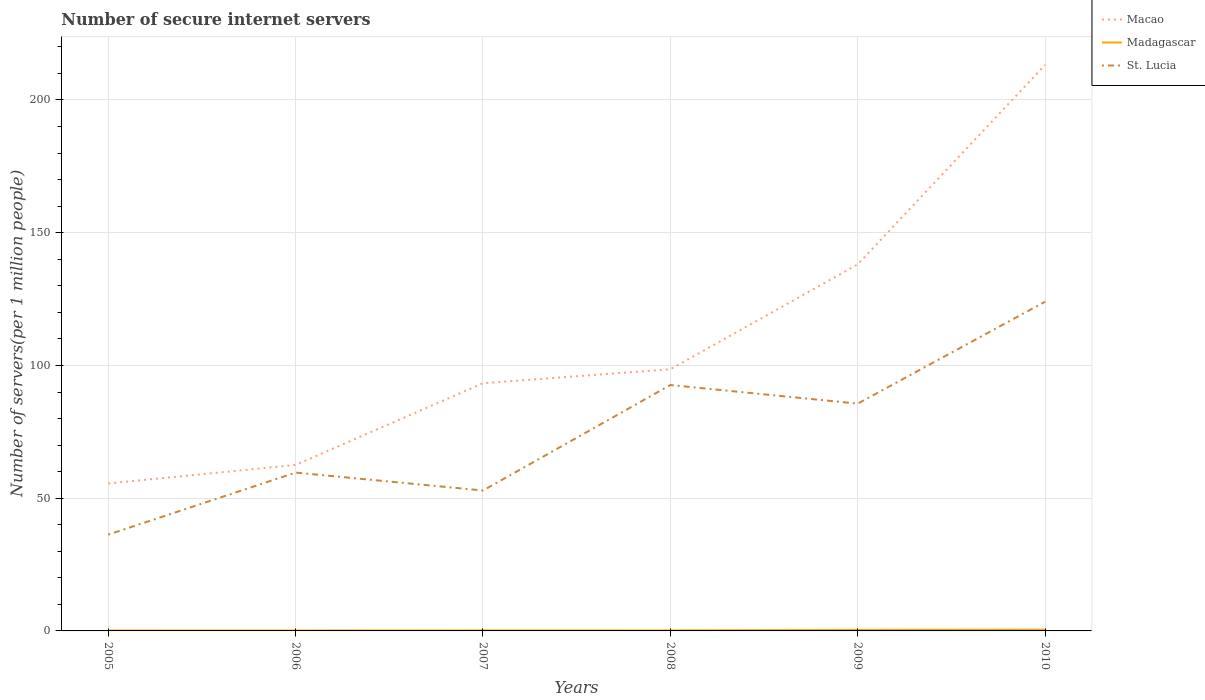How many different coloured lines are there?
Your answer should be compact. 3. Does the line corresponding to St. Lucia intersect with the line corresponding to Macao?
Provide a succinct answer. No. Across all years, what is the maximum number of secure internet servers in St. Lucia?
Keep it short and to the point. 36.27. What is the total number of secure internet servers in Macao in the graph?
Your answer should be very brief. -119.93. What is the difference between the highest and the second highest number of secure internet servers in St. Lucia?
Offer a terse response. 87.74. How many lines are there?
Offer a terse response. 3. How many years are there in the graph?
Keep it short and to the point. 6. Does the graph contain grids?
Provide a succinct answer. Yes. How are the legend labels stacked?
Your answer should be compact. Vertical. What is the title of the graph?
Your answer should be compact. Number of secure internet servers. Does "Latin America(developing only)" appear as one of the legend labels in the graph?
Offer a terse response. No. What is the label or title of the Y-axis?
Your answer should be compact. Number of servers(per 1 million people). What is the Number of servers(per 1 million people) in Macao in 2005?
Give a very brief answer. 55.54. What is the Number of servers(per 1 million people) of Madagascar in 2005?
Your answer should be very brief. 0.16. What is the Number of servers(per 1 million people) in St. Lucia in 2005?
Offer a terse response. 36.27. What is the Number of servers(per 1 million people) of Macao in 2006?
Your response must be concise. 62.54. What is the Number of servers(per 1 million people) in Madagascar in 2006?
Keep it short and to the point. 0.16. What is the Number of servers(per 1 million people) in St. Lucia in 2006?
Offer a very short reply. 59.65. What is the Number of servers(per 1 million people) in Macao in 2007?
Keep it short and to the point. 93.3. What is the Number of servers(per 1 million people) in Madagascar in 2007?
Offer a very short reply. 0.21. What is the Number of servers(per 1 million people) of St. Lucia in 2007?
Ensure brevity in your answer.  52.9. What is the Number of servers(per 1 million people) of Macao in 2008?
Your answer should be compact. 98.57. What is the Number of servers(per 1 million people) in Madagascar in 2008?
Give a very brief answer. 0.2. What is the Number of servers(per 1 million people) of St. Lucia in 2008?
Provide a succinct answer. 92.63. What is the Number of servers(per 1 million people) in Macao in 2009?
Give a very brief answer. 138.09. What is the Number of servers(per 1 million people) in Madagascar in 2009?
Make the answer very short. 0.39. What is the Number of servers(per 1 million people) of St. Lucia in 2009?
Offer a very short reply. 85.62. What is the Number of servers(per 1 million people) in Macao in 2010?
Provide a succinct answer. 213.23. What is the Number of servers(per 1 million people) in Madagascar in 2010?
Offer a terse response. 0.47. What is the Number of servers(per 1 million people) in St. Lucia in 2010?
Offer a terse response. 124.02. Across all years, what is the maximum Number of servers(per 1 million people) in Macao?
Keep it short and to the point. 213.23. Across all years, what is the maximum Number of servers(per 1 million people) in Madagascar?
Ensure brevity in your answer.  0.47. Across all years, what is the maximum Number of servers(per 1 million people) in St. Lucia?
Keep it short and to the point. 124.02. Across all years, what is the minimum Number of servers(per 1 million people) in Macao?
Provide a succinct answer. 55.54. Across all years, what is the minimum Number of servers(per 1 million people) in Madagascar?
Offer a terse response. 0.16. Across all years, what is the minimum Number of servers(per 1 million people) in St. Lucia?
Provide a succinct answer. 36.27. What is the total Number of servers(per 1 million people) in Macao in the graph?
Make the answer very short. 661.26. What is the total Number of servers(per 1 million people) of Madagascar in the graph?
Provide a short and direct response. 1.6. What is the total Number of servers(per 1 million people) of St. Lucia in the graph?
Your response must be concise. 451.08. What is the difference between the Number of servers(per 1 million people) in Macao in 2005 and that in 2006?
Offer a very short reply. -7. What is the difference between the Number of servers(per 1 million people) in Madagascar in 2005 and that in 2006?
Provide a succinct answer. 0. What is the difference between the Number of servers(per 1 million people) of St. Lucia in 2005 and that in 2006?
Ensure brevity in your answer.  -23.37. What is the difference between the Number of servers(per 1 million people) of Macao in 2005 and that in 2007?
Offer a terse response. -37.76. What is the difference between the Number of servers(per 1 million people) in Madagascar in 2005 and that in 2007?
Make the answer very short. -0.04. What is the difference between the Number of servers(per 1 million people) in St. Lucia in 2005 and that in 2007?
Keep it short and to the point. -16.62. What is the difference between the Number of servers(per 1 million people) of Macao in 2005 and that in 2008?
Your answer should be compact. -43.03. What is the difference between the Number of servers(per 1 million people) in Madagascar in 2005 and that in 2008?
Give a very brief answer. -0.04. What is the difference between the Number of servers(per 1 million people) in St. Lucia in 2005 and that in 2008?
Your answer should be very brief. -56.36. What is the difference between the Number of servers(per 1 million people) of Macao in 2005 and that in 2009?
Offer a very short reply. -82.55. What is the difference between the Number of servers(per 1 million people) in Madagascar in 2005 and that in 2009?
Your answer should be very brief. -0.23. What is the difference between the Number of servers(per 1 million people) of St. Lucia in 2005 and that in 2009?
Make the answer very short. -49.34. What is the difference between the Number of servers(per 1 million people) in Macao in 2005 and that in 2010?
Your response must be concise. -157.7. What is the difference between the Number of servers(per 1 million people) in Madagascar in 2005 and that in 2010?
Make the answer very short. -0.31. What is the difference between the Number of servers(per 1 million people) in St. Lucia in 2005 and that in 2010?
Your answer should be very brief. -87.74. What is the difference between the Number of servers(per 1 million people) in Macao in 2006 and that in 2007?
Offer a terse response. -30.77. What is the difference between the Number of servers(per 1 million people) of Madagascar in 2006 and that in 2007?
Offer a very short reply. -0.05. What is the difference between the Number of servers(per 1 million people) of St. Lucia in 2006 and that in 2007?
Your response must be concise. 6.75. What is the difference between the Number of servers(per 1 million people) of Macao in 2006 and that in 2008?
Make the answer very short. -36.03. What is the difference between the Number of servers(per 1 million people) of Madagascar in 2006 and that in 2008?
Provide a short and direct response. -0.04. What is the difference between the Number of servers(per 1 million people) of St. Lucia in 2006 and that in 2008?
Your response must be concise. -32.98. What is the difference between the Number of servers(per 1 million people) in Macao in 2006 and that in 2009?
Ensure brevity in your answer.  -75.55. What is the difference between the Number of servers(per 1 million people) of Madagascar in 2006 and that in 2009?
Offer a terse response. -0.23. What is the difference between the Number of servers(per 1 million people) of St. Lucia in 2006 and that in 2009?
Make the answer very short. -25.97. What is the difference between the Number of servers(per 1 million people) of Macao in 2006 and that in 2010?
Make the answer very short. -150.7. What is the difference between the Number of servers(per 1 million people) of Madagascar in 2006 and that in 2010?
Give a very brief answer. -0.32. What is the difference between the Number of servers(per 1 million people) of St. Lucia in 2006 and that in 2010?
Ensure brevity in your answer.  -64.37. What is the difference between the Number of servers(per 1 million people) of Macao in 2007 and that in 2008?
Your response must be concise. -5.26. What is the difference between the Number of servers(per 1 million people) in Madagascar in 2007 and that in 2008?
Make the answer very short. 0.01. What is the difference between the Number of servers(per 1 million people) in St. Lucia in 2007 and that in 2008?
Provide a succinct answer. -39.73. What is the difference between the Number of servers(per 1 million people) in Macao in 2007 and that in 2009?
Make the answer very short. -44.79. What is the difference between the Number of servers(per 1 million people) in Madagascar in 2007 and that in 2009?
Provide a succinct answer. -0.18. What is the difference between the Number of servers(per 1 million people) of St. Lucia in 2007 and that in 2009?
Give a very brief answer. -32.72. What is the difference between the Number of servers(per 1 million people) of Macao in 2007 and that in 2010?
Ensure brevity in your answer.  -119.93. What is the difference between the Number of servers(per 1 million people) in Madagascar in 2007 and that in 2010?
Your answer should be compact. -0.27. What is the difference between the Number of servers(per 1 million people) in St. Lucia in 2007 and that in 2010?
Ensure brevity in your answer.  -71.12. What is the difference between the Number of servers(per 1 million people) in Macao in 2008 and that in 2009?
Make the answer very short. -39.52. What is the difference between the Number of servers(per 1 million people) of Madagascar in 2008 and that in 2009?
Provide a succinct answer. -0.19. What is the difference between the Number of servers(per 1 million people) of St. Lucia in 2008 and that in 2009?
Make the answer very short. 7.01. What is the difference between the Number of servers(per 1 million people) of Macao in 2008 and that in 2010?
Provide a short and direct response. -114.67. What is the difference between the Number of servers(per 1 million people) of Madagascar in 2008 and that in 2010?
Provide a succinct answer. -0.27. What is the difference between the Number of servers(per 1 million people) in St. Lucia in 2008 and that in 2010?
Your response must be concise. -31.39. What is the difference between the Number of servers(per 1 million people) of Macao in 2009 and that in 2010?
Give a very brief answer. -75.14. What is the difference between the Number of servers(per 1 million people) of Madagascar in 2009 and that in 2010?
Your response must be concise. -0.08. What is the difference between the Number of servers(per 1 million people) of St. Lucia in 2009 and that in 2010?
Your response must be concise. -38.4. What is the difference between the Number of servers(per 1 million people) of Macao in 2005 and the Number of servers(per 1 million people) of Madagascar in 2006?
Your answer should be very brief. 55.38. What is the difference between the Number of servers(per 1 million people) in Macao in 2005 and the Number of servers(per 1 million people) in St. Lucia in 2006?
Your response must be concise. -4.11. What is the difference between the Number of servers(per 1 million people) of Madagascar in 2005 and the Number of servers(per 1 million people) of St. Lucia in 2006?
Your answer should be very brief. -59.48. What is the difference between the Number of servers(per 1 million people) in Macao in 2005 and the Number of servers(per 1 million people) in Madagascar in 2007?
Ensure brevity in your answer.  55.33. What is the difference between the Number of servers(per 1 million people) of Macao in 2005 and the Number of servers(per 1 million people) of St. Lucia in 2007?
Make the answer very short. 2.64. What is the difference between the Number of servers(per 1 million people) in Madagascar in 2005 and the Number of servers(per 1 million people) in St. Lucia in 2007?
Offer a terse response. -52.73. What is the difference between the Number of servers(per 1 million people) of Macao in 2005 and the Number of servers(per 1 million people) of Madagascar in 2008?
Provide a short and direct response. 55.34. What is the difference between the Number of servers(per 1 million people) in Macao in 2005 and the Number of servers(per 1 million people) in St. Lucia in 2008?
Offer a very short reply. -37.09. What is the difference between the Number of servers(per 1 million people) of Madagascar in 2005 and the Number of servers(per 1 million people) of St. Lucia in 2008?
Provide a short and direct response. -92.47. What is the difference between the Number of servers(per 1 million people) of Macao in 2005 and the Number of servers(per 1 million people) of Madagascar in 2009?
Ensure brevity in your answer.  55.15. What is the difference between the Number of servers(per 1 million people) of Macao in 2005 and the Number of servers(per 1 million people) of St. Lucia in 2009?
Keep it short and to the point. -30.08. What is the difference between the Number of servers(per 1 million people) of Madagascar in 2005 and the Number of servers(per 1 million people) of St. Lucia in 2009?
Give a very brief answer. -85.45. What is the difference between the Number of servers(per 1 million people) in Macao in 2005 and the Number of servers(per 1 million people) in Madagascar in 2010?
Give a very brief answer. 55.06. What is the difference between the Number of servers(per 1 million people) in Macao in 2005 and the Number of servers(per 1 million people) in St. Lucia in 2010?
Your response must be concise. -68.48. What is the difference between the Number of servers(per 1 million people) of Madagascar in 2005 and the Number of servers(per 1 million people) of St. Lucia in 2010?
Offer a very short reply. -123.85. What is the difference between the Number of servers(per 1 million people) in Macao in 2006 and the Number of servers(per 1 million people) in Madagascar in 2007?
Offer a terse response. 62.33. What is the difference between the Number of servers(per 1 million people) of Macao in 2006 and the Number of servers(per 1 million people) of St. Lucia in 2007?
Provide a short and direct response. 9.64. What is the difference between the Number of servers(per 1 million people) of Madagascar in 2006 and the Number of servers(per 1 million people) of St. Lucia in 2007?
Offer a very short reply. -52.74. What is the difference between the Number of servers(per 1 million people) of Macao in 2006 and the Number of servers(per 1 million people) of Madagascar in 2008?
Ensure brevity in your answer.  62.33. What is the difference between the Number of servers(per 1 million people) of Macao in 2006 and the Number of servers(per 1 million people) of St. Lucia in 2008?
Offer a very short reply. -30.1. What is the difference between the Number of servers(per 1 million people) in Madagascar in 2006 and the Number of servers(per 1 million people) in St. Lucia in 2008?
Keep it short and to the point. -92.47. What is the difference between the Number of servers(per 1 million people) of Macao in 2006 and the Number of servers(per 1 million people) of Madagascar in 2009?
Provide a short and direct response. 62.15. What is the difference between the Number of servers(per 1 million people) of Macao in 2006 and the Number of servers(per 1 million people) of St. Lucia in 2009?
Your answer should be very brief. -23.08. What is the difference between the Number of servers(per 1 million people) of Madagascar in 2006 and the Number of servers(per 1 million people) of St. Lucia in 2009?
Make the answer very short. -85.46. What is the difference between the Number of servers(per 1 million people) in Macao in 2006 and the Number of servers(per 1 million people) in Madagascar in 2010?
Ensure brevity in your answer.  62.06. What is the difference between the Number of servers(per 1 million people) of Macao in 2006 and the Number of servers(per 1 million people) of St. Lucia in 2010?
Keep it short and to the point. -61.48. What is the difference between the Number of servers(per 1 million people) in Madagascar in 2006 and the Number of servers(per 1 million people) in St. Lucia in 2010?
Provide a short and direct response. -123.86. What is the difference between the Number of servers(per 1 million people) of Macao in 2007 and the Number of servers(per 1 million people) of Madagascar in 2008?
Offer a very short reply. 93.1. What is the difference between the Number of servers(per 1 million people) in Macao in 2007 and the Number of servers(per 1 million people) in St. Lucia in 2008?
Provide a succinct answer. 0.67. What is the difference between the Number of servers(per 1 million people) in Madagascar in 2007 and the Number of servers(per 1 million people) in St. Lucia in 2008?
Offer a very short reply. -92.42. What is the difference between the Number of servers(per 1 million people) of Macao in 2007 and the Number of servers(per 1 million people) of Madagascar in 2009?
Provide a succinct answer. 92.91. What is the difference between the Number of servers(per 1 million people) in Macao in 2007 and the Number of servers(per 1 million people) in St. Lucia in 2009?
Keep it short and to the point. 7.68. What is the difference between the Number of servers(per 1 million people) of Madagascar in 2007 and the Number of servers(per 1 million people) of St. Lucia in 2009?
Offer a terse response. -85.41. What is the difference between the Number of servers(per 1 million people) in Macao in 2007 and the Number of servers(per 1 million people) in Madagascar in 2010?
Provide a succinct answer. 92.83. What is the difference between the Number of servers(per 1 million people) in Macao in 2007 and the Number of servers(per 1 million people) in St. Lucia in 2010?
Offer a very short reply. -30.71. What is the difference between the Number of servers(per 1 million people) of Madagascar in 2007 and the Number of servers(per 1 million people) of St. Lucia in 2010?
Make the answer very short. -123.81. What is the difference between the Number of servers(per 1 million people) in Macao in 2008 and the Number of servers(per 1 million people) in Madagascar in 2009?
Provide a short and direct response. 98.18. What is the difference between the Number of servers(per 1 million people) of Macao in 2008 and the Number of servers(per 1 million people) of St. Lucia in 2009?
Your response must be concise. 12.95. What is the difference between the Number of servers(per 1 million people) of Madagascar in 2008 and the Number of servers(per 1 million people) of St. Lucia in 2009?
Your answer should be very brief. -85.42. What is the difference between the Number of servers(per 1 million people) in Macao in 2008 and the Number of servers(per 1 million people) in Madagascar in 2010?
Give a very brief answer. 98.09. What is the difference between the Number of servers(per 1 million people) of Macao in 2008 and the Number of servers(per 1 million people) of St. Lucia in 2010?
Make the answer very short. -25.45. What is the difference between the Number of servers(per 1 million people) of Madagascar in 2008 and the Number of servers(per 1 million people) of St. Lucia in 2010?
Make the answer very short. -123.81. What is the difference between the Number of servers(per 1 million people) of Macao in 2009 and the Number of servers(per 1 million people) of Madagascar in 2010?
Offer a very short reply. 137.61. What is the difference between the Number of servers(per 1 million people) in Macao in 2009 and the Number of servers(per 1 million people) in St. Lucia in 2010?
Your response must be concise. 14.07. What is the difference between the Number of servers(per 1 million people) of Madagascar in 2009 and the Number of servers(per 1 million people) of St. Lucia in 2010?
Give a very brief answer. -123.63. What is the average Number of servers(per 1 million people) of Macao per year?
Provide a short and direct response. 110.21. What is the average Number of servers(per 1 million people) in Madagascar per year?
Your response must be concise. 0.27. What is the average Number of servers(per 1 million people) in St. Lucia per year?
Offer a very short reply. 75.18. In the year 2005, what is the difference between the Number of servers(per 1 million people) in Macao and Number of servers(per 1 million people) in Madagascar?
Offer a very short reply. 55.37. In the year 2005, what is the difference between the Number of servers(per 1 million people) of Macao and Number of servers(per 1 million people) of St. Lucia?
Offer a very short reply. 19.26. In the year 2005, what is the difference between the Number of servers(per 1 million people) of Madagascar and Number of servers(per 1 million people) of St. Lucia?
Provide a succinct answer. -36.11. In the year 2006, what is the difference between the Number of servers(per 1 million people) of Macao and Number of servers(per 1 million people) of Madagascar?
Offer a very short reply. 62.38. In the year 2006, what is the difference between the Number of servers(per 1 million people) in Macao and Number of servers(per 1 million people) in St. Lucia?
Keep it short and to the point. 2.89. In the year 2006, what is the difference between the Number of servers(per 1 million people) of Madagascar and Number of servers(per 1 million people) of St. Lucia?
Offer a terse response. -59.49. In the year 2007, what is the difference between the Number of servers(per 1 million people) in Macao and Number of servers(per 1 million people) in Madagascar?
Make the answer very short. 93.1. In the year 2007, what is the difference between the Number of servers(per 1 million people) in Macao and Number of servers(per 1 million people) in St. Lucia?
Provide a short and direct response. 40.41. In the year 2007, what is the difference between the Number of servers(per 1 million people) in Madagascar and Number of servers(per 1 million people) in St. Lucia?
Your answer should be very brief. -52.69. In the year 2008, what is the difference between the Number of servers(per 1 million people) in Macao and Number of servers(per 1 million people) in Madagascar?
Keep it short and to the point. 98.37. In the year 2008, what is the difference between the Number of servers(per 1 million people) of Macao and Number of servers(per 1 million people) of St. Lucia?
Ensure brevity in your answer.  5.94. In the year 2008, what is the difference between the Number of servers(per 1 million people) in Madagascar and Number of servers(per 1 million people) in St. Lucia?
Provide a short and direct response. -92.43. In the year 2009, what is the difference between the Number of servers(per 1 million people) of Macao and Number of servers(per 1 million people) of Madagascar?
Your answer should be very brief. 137.7. In the year 2009, what is the difference between the Number of servers(per 1 million people) in Macao and Number of servers(per 1 million people) in St. Lucia?
Make the answer very short. 52.47. In the year 2009, what is the difference between the Number of servers(per 1 million people) in Madagascar and Number of servers(per 1 million people) in St. Lucia?
Your answer should be compact. -85.23. In the year 2010, what is the difference between the Number of servers(per 1 million people) of Macao and Number of servers(per 1 million people) of Madagascar?
Keep it short and to the point. 212.76. In the year 2010, what is the difference between the Number of servers(per 1 million people) of Macao and Number of servers(per 1 million people) of St. Lucia?
Provide a succinct answer. 89.22. In the year 2010, what is the difference between the Number of servers(per 1 million people) in Madagascar and Number of servers(per 1 million people) in St. Lucia?
Offer a very short reply. -123.54. What is the ratio of the Number of servers(per 1 million people) of Macao in 2005 to that in 2006?
Give a very brief answer. 0.89. What is the ratio of the Number of servers(per 1 million people) of Madagascar in 2005 to that in 2006?
Make the answer very short. 1.03. What is the ratio of the Number of servers(per 1 million people) of St. Lucia in 2005 to that in 2006?
Give a very brief answer. 0.61. What is the ratio of the Number of servers(per 1 million people) in Macao in 2005 to that in 2007?
Offer a very short reply. 0.6. What is the ratio of the Number of servers(per 1 million people) of Madagascar in 2005 to that in 2007?
Your answer should be very brief. 0.79. What is the ratio of the Number of servers(per 1 million people) in St. Lucia in 2005 to that in 2007?
Offer a very short reply. 0.69. What is the ratio of the Number of servers(per 1 million people) of Macao in 2005 to that in 2008?
Your response must be concise. 0.56. What is the ratio of the Number of servers(per 1 million people) of Madagascar in 2005 to that in 2008?
Your answer should be compact. 0.82. What is the ratio of the Number of servers(per 1 million people) in St. Lucia in 2005 to that in 2008?
Provide a succinct answer. 0.39. What is the ratio of the Number of servers(per 1 million people) of Macao in 2005 to that in 2009?
Keep it short and to the point. 0.4. What is the ratio of the Number of servers(per 1 million people) of Madagascar in 2005 to that in 2009?
Your response must be concise. 0.42. What is the ratio of the Number of servers(per 1 million people) of St. Lucia in 2005 to that in 2009?
Provide a short and direct response. 0.42. What is the ratio of the Number of servers(per 1 million people) in Macao in 2005 to that in 2010?
Make the answer very short. 0.26. What is the ratio of the Number of servers(per 1 million people) of Madagascar in 2005 to that in 2010?
Keep it short and to the point. 0.35. What is the ratio of the Number of servers(per 1 million people) of St. Lucia in 2005 to that in 2010?
Provide a short and direct response. 0.29. What is the ratio of the Number of servers(per 1 million people) in Macao in 2006 to that in 2007?
Provide a short and direct response. 0.67. What is the ratio of the Number of servers(per 1 million people) in Madagascar in 2006 to that in 2007?
Your answer should be compact. 0.77. What is the ratio of the Number of servers(per 1 million people) of St. Lucia in 2006 to that in 2007?
Provide a succinct answer. 1.13. What is the ratio of the Number of servers(per 1 million people) in Macao in 2006 to that in 2008?
Provide a short and direct response. 0.63. What is the ratio of the Number of servers(per 1 million people) in Madagascar in 2006 to that in 2008?
Provide a short and direct response. 0.79. What is the ratio of the Number of servers(per 1 million people) of St. Lucia in 2006 to that in 2008?
Your response must be concise. 0.64. What is the ratio of the Number of servers(per 1 million people) in Macao in 2006 to that in 2009?
Provide a succinct answer. 0.45. What is the ratio of the Number of servers(per 1 million people) in Madagascar in 2006 to that in 2009?
Provide a short and direct response. 0.41. What is the ratio of the Number of servers(per 1 million people) in St. Lucia in 2006 to that in 2009?
Make the answer very short. 0.7. What is the ratio of the Number of servers(per 1 million people) of Macao in 2006 to that in 2010?
Offer a terse response. 0.29. What is the ratio of the Number of servers(per 1 million people) of Madagascar in 2006 to that in 2010?
Make the answer very short. 0.34. What is the ratio of the Number of servers(per 1 million people) of St. Lucia in 2006 to that in 2010?
Your answer should be compact. 0.48. What is the ratio of the Number of servers(per 1 million people) in Macao in 2007 to that in 2008?
Provide a short and direct response. 0.95. What is the ratio of the Number of servers(per 1 million people) of Madagascar in 2007 to that in 2008?
Your answer should be compact. 1.03. What is the ratio of the Number of servers(per 1 million people) of St. Lucia in 2007 to that in 2008?
Your response must be concise. 0.57. What is the ratio of the Number of servers(per 1 million people) in Macao in 2007 to that in 2009?
Make the answer very short. 0.68. What is the ratio of the Number of servers(per 1 million people) in Madagascar in 2007 to that in 2009?
Make the answer very short. 0.53. What is the ratio of the Number of servers(per 1 million people) in St. Lucia in 2007 to that in 2009?
Provide a short and direct response. 0.62. What is the ratio of the Number of servers(per 1 million people) in Macao in 2007 to that in 2010?
Keep it short and to the point. 0.44. What is the ratio of the Number of servers(per 1 million people) of Madagascar in 2007 to that in 2010?
Ensure brevity in your answer.  0.44. What is the ratio of the Number of servers(per 1 million people) in St. Lucia in 2007 to that in 2010?
Offer a very short reply. 0.43. What is the ratio of the Number of servers(per 1 million people) in Macao in 2008 to that in 2009?
Offer a very short reply. 0.71. What is the ratio of the Number of servers(per 1 million people) of Madagascar in 2008 to that in 2009?
Give a very brief answer. 0.51. What is the ratio of the Number of servers(per 1 million people) of St. Lucia in 2008 to that in 2009?
Provide a succinct answer. 1.08. What is the ratio of the Number of servers(per 1 million people) of Macao in 2008 to that in 2010?
Keep it short and to the point. 0.46. What is the ratio of the Number of servers(per 1 million people) in Madagascar in 2008 to that in 2010?
Ensure brevity in your answer.  0.42. What is the ratio of the Number of servers(per 1 million people) in St. Lucia in 2008 to that in 2010?
Ensure brevity in your answer.  0.75. What is the ratio of the Number of servers(per 1 million people) in Macao in 2009 to that in 2010?
Provide a short and direct response. 0.65. What is the ratio of the Number of servers(per 1 million people) of Madagascar in 2009 to that in 2010?
Give a very brief answer. 0.82. What is the ratio of the Number of servers(per 1 million people) in St. Lucia in 2009 to that in 2010?
Ensure brevity in your answer.  0.69. What is the difference between the highest and the second highest Number of servers(per 1 million people) of Macao?
Provide a short and direct response. 75.14. What is the difference between the highest and the second highest Number of servers(per 1 million people) in Madagascar?
Your answer should be very brief. 0.08. What is the difference between the highest and the second highest Number of servers(per 1 million people) of St. Lucia?
Offer a terse response. 31.39. What is the difference between the highest and the lowest Number of servers(per 1 million people) of Macao?
Offer a very short reply. 157.7. What is the difference between the highest and the lowest Number of servers(per 1 million people) in Madagascar?
Make the answer very short. 0.32. What is the difference between the highest and the lowest Number of servers(per 1 million people) of St. Lucia?
Make the answer very short. 87.74. 